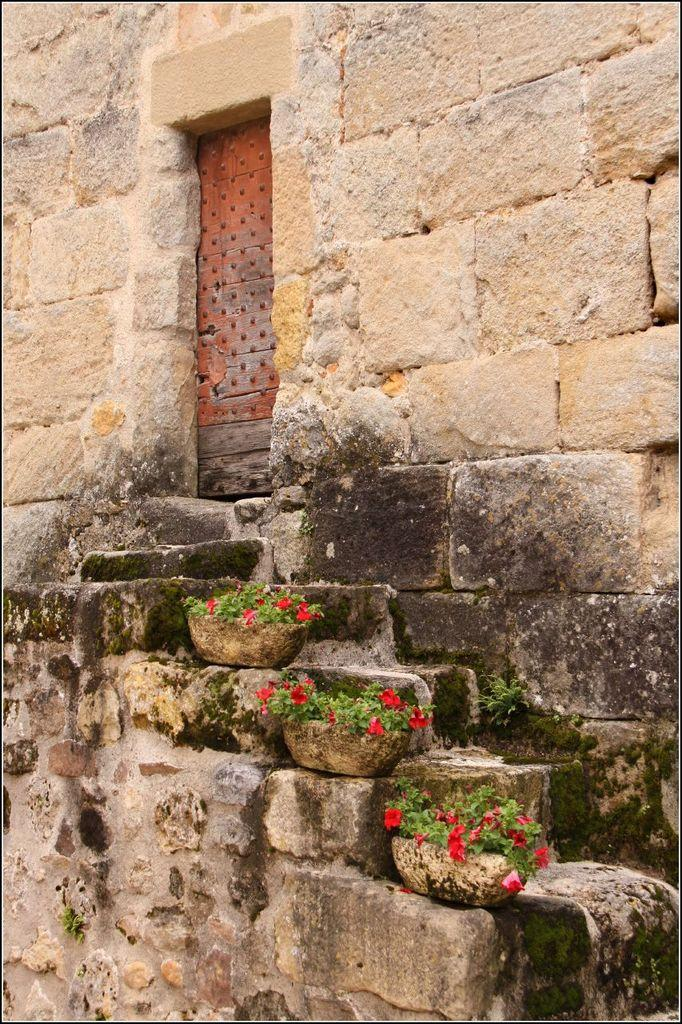What type of structure can be seen in the image? There is a wall in the image. What can be found near the wall? There are flower pots in the image. Are there any architectural features visible in the image? Yes, there are steps in the image. What is a possible entrance or exit in the image? There is a door in the image. What type of afterthought can be seen in the image? There is no afterthought present in the image. What type of zinc object can be seen in the image? There is no zinc object present in the image. 